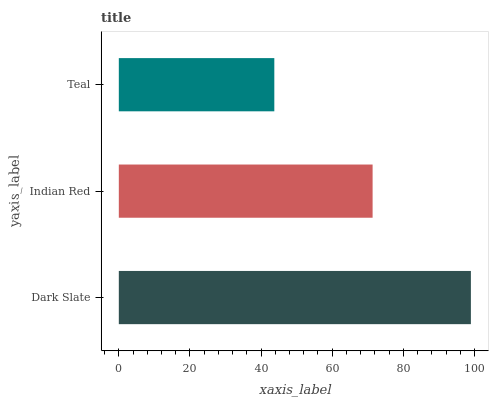Is Teal the minimum?
Answer yes or no. Yes. Is Dark Slate the maximum?
Answer yes or no. Yes. Is Indian Red the minimum?
Answer yes or no. No. Is Indian Red the maximum?
Answer yes or no. No. Is Dark Slate greater than Indian Red?
Answer yes or no. Yes. Is Indian Red less than Dark Slate?
Answer yes or no. Yes. Is Indian Red greater than Dark Slate?
Answer yes or no. No. Is Dark Slate less than Indian Red?
Answer yes or no. No. Is Indian Red the high median?
Answer yes or no. Yes. Is Indian Red the low median?
Answer yes or no. Yes. Is Teal the high median?
Answer yes or no. No. Is Teal the low median?
Answer yes or no. No. 